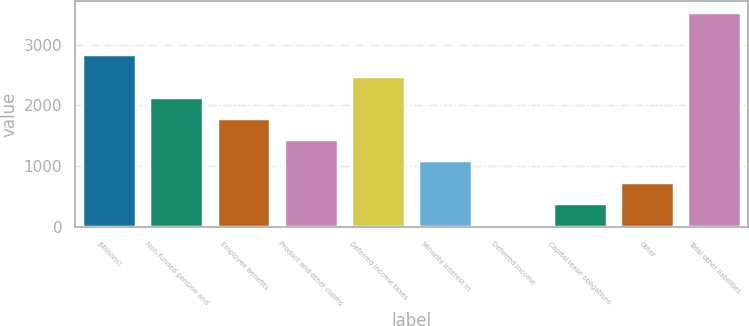Convert chart to OTSL. <chart><loc_0><loc_0><loc_500><loc_500><bar_chart><fcel>(Millions)<fcel>Non-funded pension and<fcel>Employee benefits<fcel>Product and other claims<fcel>Deferred income taxes<fcel>Minority interest in<fcel>Deferred income<fcel>Capital lease obligations<fcel>Other<fcel>Total other liabilities<nl><fcel>2836.6<fcel>2141.2<fcel>1793.5<fcel>1445.8<fcel>2488.9<fcel>1098.1<fcel>55<fcel>402.7<fcel>750.4<fcel>3532<nl></chart> 